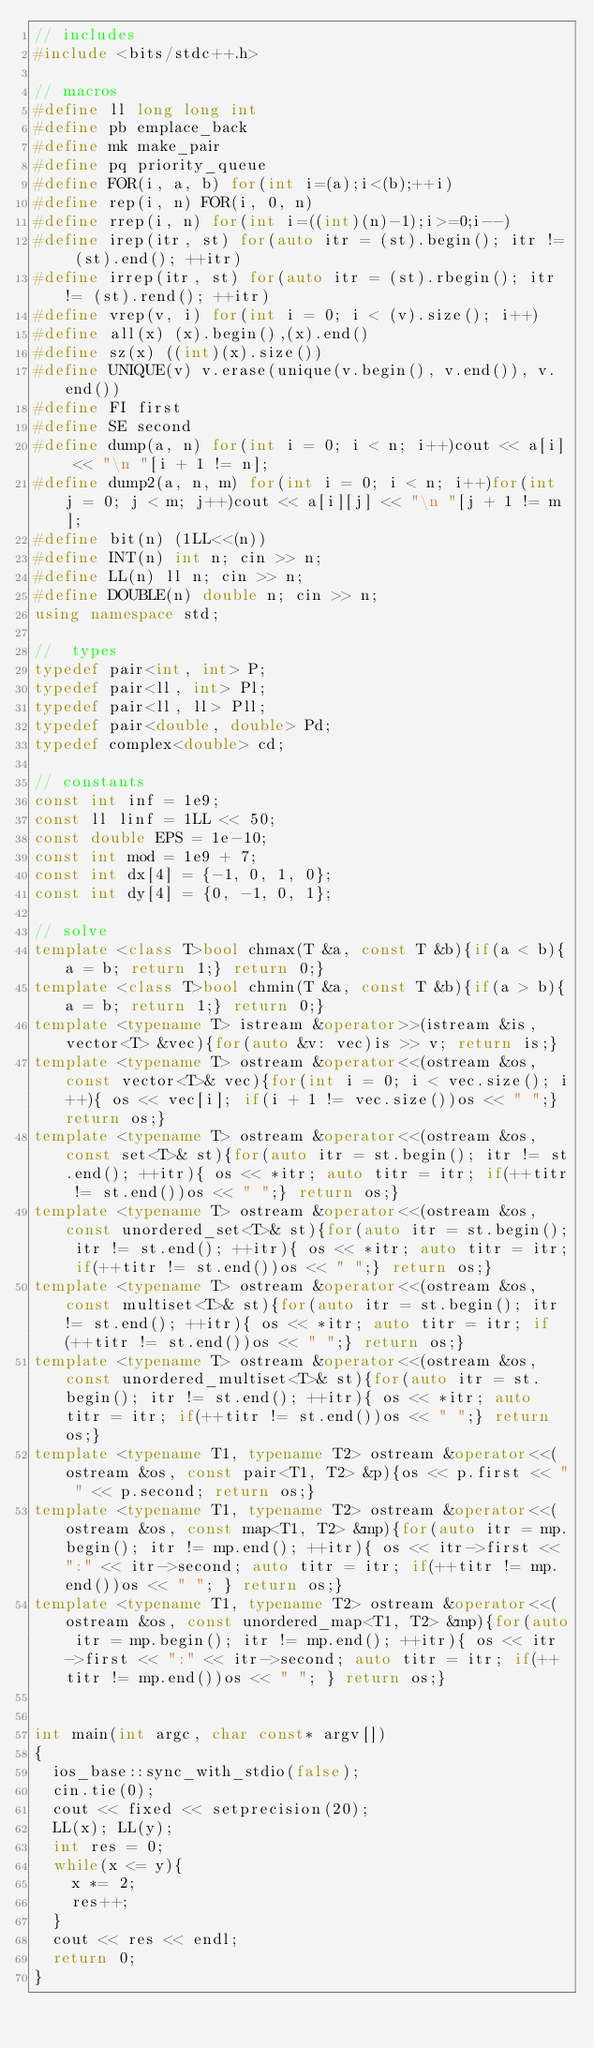<code> <loc_0><loc_0><loc_500><loc_500><_C++_>// includes
#include <bits/stdc++.h>

// macros
#define ll long long int
#define pb emplace_back
#define mk make_pair
#define pq priority_queue
#define FOR(i, a, b) for(int i=(a);i<(b);++i)
#define rep(i, n) FOR(i, 0, n)
#define rrep(i, n) for(int i=((int)(n)-1);i>=0;i--)
#define irep(itr, st) for(auto itr = (st).begin(); itr != (st).end(); ++itr)
#define irrep(itr, st) for(auto itr = (st).rbegin(); itr != (st).rend(); ++itr)
#define vrep(v, i) for(int i = 0; i < (v).size(); i++)
#define all(x) (x).begin(),(x).end()
#define sz(x) ((int)(x).size())
#define UNIQUE(v) v.erase(unique(v.begin(), v.end()), v.end())
#define FI first
#define SE second
#define dump(a, n) for(int i = 0; i < n; i++)cout << a[i] << "\n "[i + 1 != n];
#define dump2(a, n, m) for(int i = 0; i < n; i++)for(int j = 0; j < m; j++)cout << a[i][j] << "\n "[j + 1 != m];
#define bit(n) (1LL<<(n))
#define INT(n) int n; cin >> n;
#define LL(n) ll n; cin >> n;
#define DOUBLE(n) double n; cin >> n;
using namespace std;

//  types
typedef pair<int, int> P;
typedef pair<ll, int> Pl;
typedef pair<ll, ll> Pll;
typedef pair<double, double> Pd;
typedef complex<double> cd;
 
// constants
const int inf = 1e9;
const ll linf = 1LL << 50;
const double EPS = 1e-10;
const int mod = 1e9 + 7;
const int dx[4] = {-1, 0, 1, 0};
const int dy[4] = {0, -1, 0, 1};

// solve
template <class T>bool chmax(T &a, const T &b){if(a < b){a = b; return 1;} return 0;}
template <class T>bool chmin(T &a, const T &b){if(a > b){a = b; return 1;} return 0;}
template <typename T> istream &operator>>(istream &is, vector<T> &vec){for(auto &v: vec)is >> v; return is;}
template <typename T> ostream &operator<<(ostream &os, const vector<T>& vec){for(int i = 0; i < vec.size(); i++){ os << vec[i]; if(i + 1 != vec.size())os << " ";} return os;}
template <typename T> ostream &operator<<(ostream &os, const set<T>& st){for(auto itr = st.begin(); itr != st.end(); ++itr){ os << *itr; auto titr = itr; if(++titr != st.end())os << " ";} return os;}
template <typename T> ostream &operator<<(ostream &os, const unordered_set<T>& st){for(auto itr = st.begin(); itr != st.end(); ++itr){ os << *itr; auto titr = itr; if(++titr != st.end())os << " ";} return os;}
template <typename T> ostream &operator<<(ostream &os, const multiset<T>& st){for(auto itr = st.begin(); itr != st.end(); ++itr){ os << *itr; auto titr = itr; if(++titr != st.end())os << " ";} return os;}
template <typename T> ostream &operator<<(ostream &os, const unordered_multiset<T>& st){for(auto itr = st.begin(); itr != st.end(); ++itr){ os << *itr; auto titr = itr; if(++titr != st.end())os << " ";} return os;}
template <typename T1, typename T2> ostream &operator<<(ostream &os, const pair<T1, T2> &p){os << p.first << " " << p.second; return os;}
template <typename T1, typename T2> ostream &operator<<(ostream &os, const map<T1, T2> &mp){for(auto itr = mp.begin(); itr != mp.end(); ++itr){ os << itr->first << ":" << itr->second; auto titr = itr; if(++titr != mp.end())os << " "; } return os;}
template <typename T1, typename T2> ostream &operator<<(ostream &os, const unordered_map<T1, T2> &mp){for(auto itr = mp.begin(); itr != mp.end(); ++itr){ os << itr->first << ":" << itr->second; auto titr = itr; if(++titr != mp.end())os << " "; } return os;}


int main(int argc, char const* argv[])
{
  ios_base::sync_with_stdio(false);
  cin.tie(0);
  cout << fixed << setprecision(20);
  LL(x); LL(y);
  int res = 0;
  while(x <= y){
    x *= 2;
    res++;
  }
  cout << res << endl;
  return 0;
}
</code> 